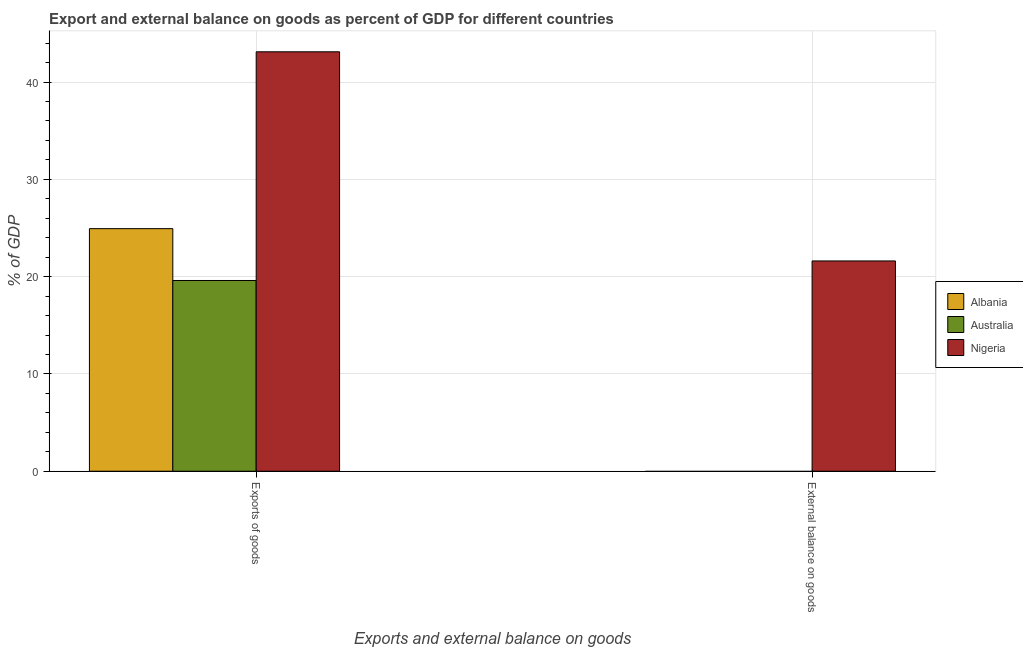How many bars are there on the 2nd tick from the left?
Offer a very short reply. 1. What is the label of the 2nd group of bars from the left?
Your response must be concise. External balance on goods. What is the export of goods as percentage of gdp in Australia?
Provide a succinct answer. 19.6. Across all countries, what is the maximum external balance on goods as percentage of gdp?
Your response must be concise. 21.61. Across all countries, what is the minimum external balance on goods as percentage of gdp?
Provide a succinct answer. 0. In which country was the external balance on goods as percentage of gdp maximum?
Your answer should be compact. Nigeria. What is the total external balance on goods as percentage of gdp in the graph?
Offer a terse response. 21.61. What is the difference between the export of goods as percentage of gdp in Albania and that in Nigeria?
Your answer should be very brief. -18.18. What is the difference between the external balance on goods as percentage of gdp in Albania and the export of goods as percentage of gdp in Nigeria?
Your answer should be compact. -43.11. What is the average export of goods as percentage of gdp per country?
Your answer should be very brief. 29.22. What is the difference between the external balance on goods as percentage of gdp and export of goods as percentage of gdp in Nigeria?
Offer a terse response. -21.5. What is the ratio of the export of goods as percentage of gdp in Nigeria to that in Albania?
Provide a short and direct response. 1.73. In how many countries, is the export of goods as percentage of gdp greater than the average export of goods as percentage of gdp taken over all countries?
Give a very brief answer. 1. How many countries are there in the graph?
Your answer should be very brief. 3. Are the values on the major ticks of Y-axis written in scientific E-notation?
Make the answer very short. No. Does the graph contain any zero values?
Give a very brief answer. Yes. How many legend labels are there?
Ensure brevity in your answer.  3. What is the title of the graph?
Give a very brief answer. Export and external balance on goods as percent of GDP for different countries. Does "Comoros" appear as one of the legend labels in the graph?
Your answer should be very brief. No. What is the label or title of the X-axis?
Your response must be concise. Exports and external balance on goods. What is the label or title of the Y-axis?
Your response must be concise. % of GDP. What is the % of GDP in Albania in Exports of goods?
Make the answer very short. 24.93. What is the % of GDP of Australia in Exports of goods?
Keep it short and to the point. 19.6. What is the % of GDP in Nigeria in Exports of goods?
Provide a short and direct response. 43.11. What is the % of GDP in Albania in External balance on goods?
Make the answer very short. 0. What is the % of GDP of Australia in External balance on goods?
Your response must be concise. 0. What is the % of GDP of Nigeria in External balance on goods?
Offer a terse response. 21.61. Across all Exports and external balance on goods, what is the maximum % of GDP of Albania?
Your response must be concise. 24.93. Across all Exports and external balance on goods, what is the maximum % of GDP of Australia?
Provide a succinct answer. 19.6. Across all Exports and external balance on goods, what is the maximum % of GDP of Nigeria?
Offer a terse response. 43.11. Across all Exports and external balance on goods, what is the minimum % of GDP of Albania?
Make the answer very short. 0. Across all Exports and external balance on goods, what is the minimum % of GDP in Australia?
Give a very brief answer. 0. Across all Exports and external balance on goods, what is the minimum % of GDP in Nigeria?
Keep it short and to the point. 21.61. What is the total % of GDP of Albania in the graph?
Provide a succinct answer. 24.93. What is the total % of GDP of Australia in the graph?
Make the answer very short. 19.6. What is the total % of GDP in Nigeria in the graph?
Make the answer very short. 64.72. What is the difference between the % of GDP of Nigeria in Exports of goods and that in External balance on goods?
Offer a very short reply. 21.5. What is the difference between the % of GDP of Albania in Exports of goods and the % of GDP of Nigeria in External balance on goods?
Give a very brief answer. 3.32. What is the difference between the % of GDP in Australia in Exports of goods and the % of GDP in Nigeria in External balance on goods?
Provide a succinct answer. -2.01. What is the average % of GDP in Albania per Exports and external balance on goods?
Your answer should be compact. 12.47. What is the average % of GDP in Australia per Exports and external balance on goods?
Your response must be concise. 9.8. What is the average % of GDP of Nigeria per Exports and external balance on goods?
Provide a short and direct response. 32.36. What is the difference between the % of GDP in Albania and % of GDP in Australia in Exports of goods?
Keep it short and to the point. 5.33. What is the difference between the % of GDP of Albania and % of GDP of Nigeria in Exports of goods?
Your answer should be very brief. -18.18. What is the difference between the % of GDP in Australia and % of GDP in Nigeria in Exports of goods?
Offer a terse response. -23.51. What is the ratio of the % of GDP in Nigeria in Exports of goods to that in External balance on goods?
Ensure brevity in your answer.  1.99. What is the difference between the highest and the second highest % of GDP in Nigeria?
Provide a succinct answer. 21.5. What is the difference between the highest and the lowest % of GDP of Albania?
Offer a terse response. 24.93. What is the difference between the highest and the lowest % of GDP in Australia?
Ensure brevity in your answer.  19.6. What is the difference between the highest and the lowest % of GDP of Nigeria?
Provide a succinct answer. 21.5. 